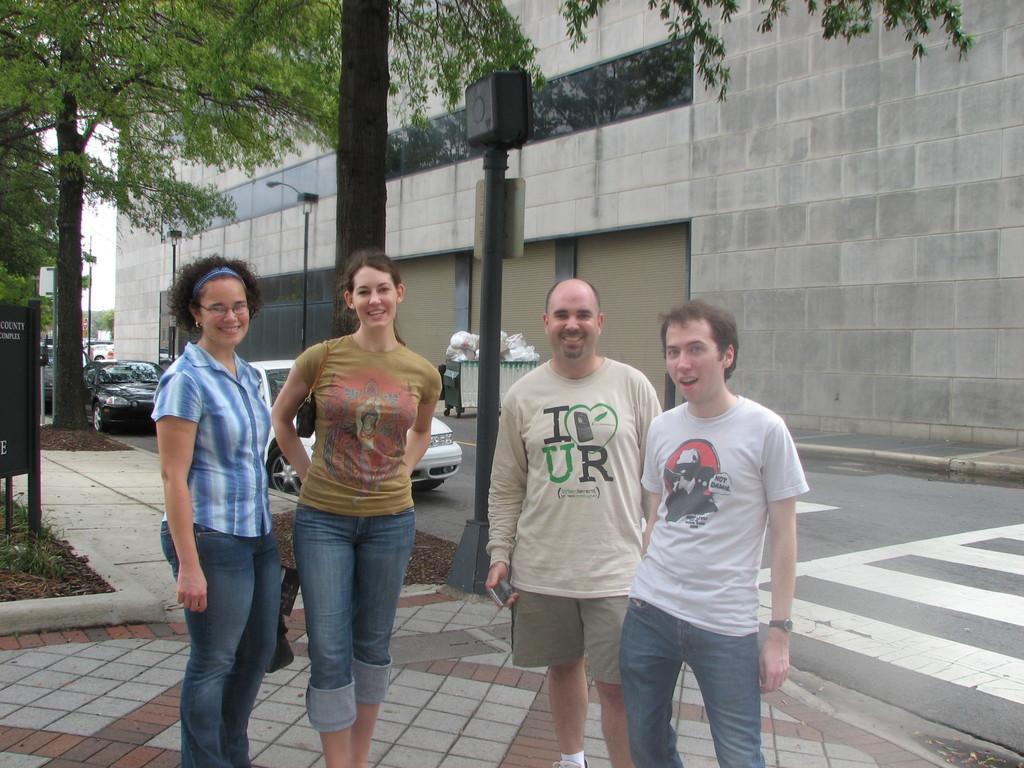Could you give a brief overview of what you see in this image? There are two women and two men smiling and standing on the footpath near a road on which, there is a zebra crossing and there are vehicles. In the background, there are trees, a pole, hoarding and grass on the ground, building which is having glass windows and there is sky. 